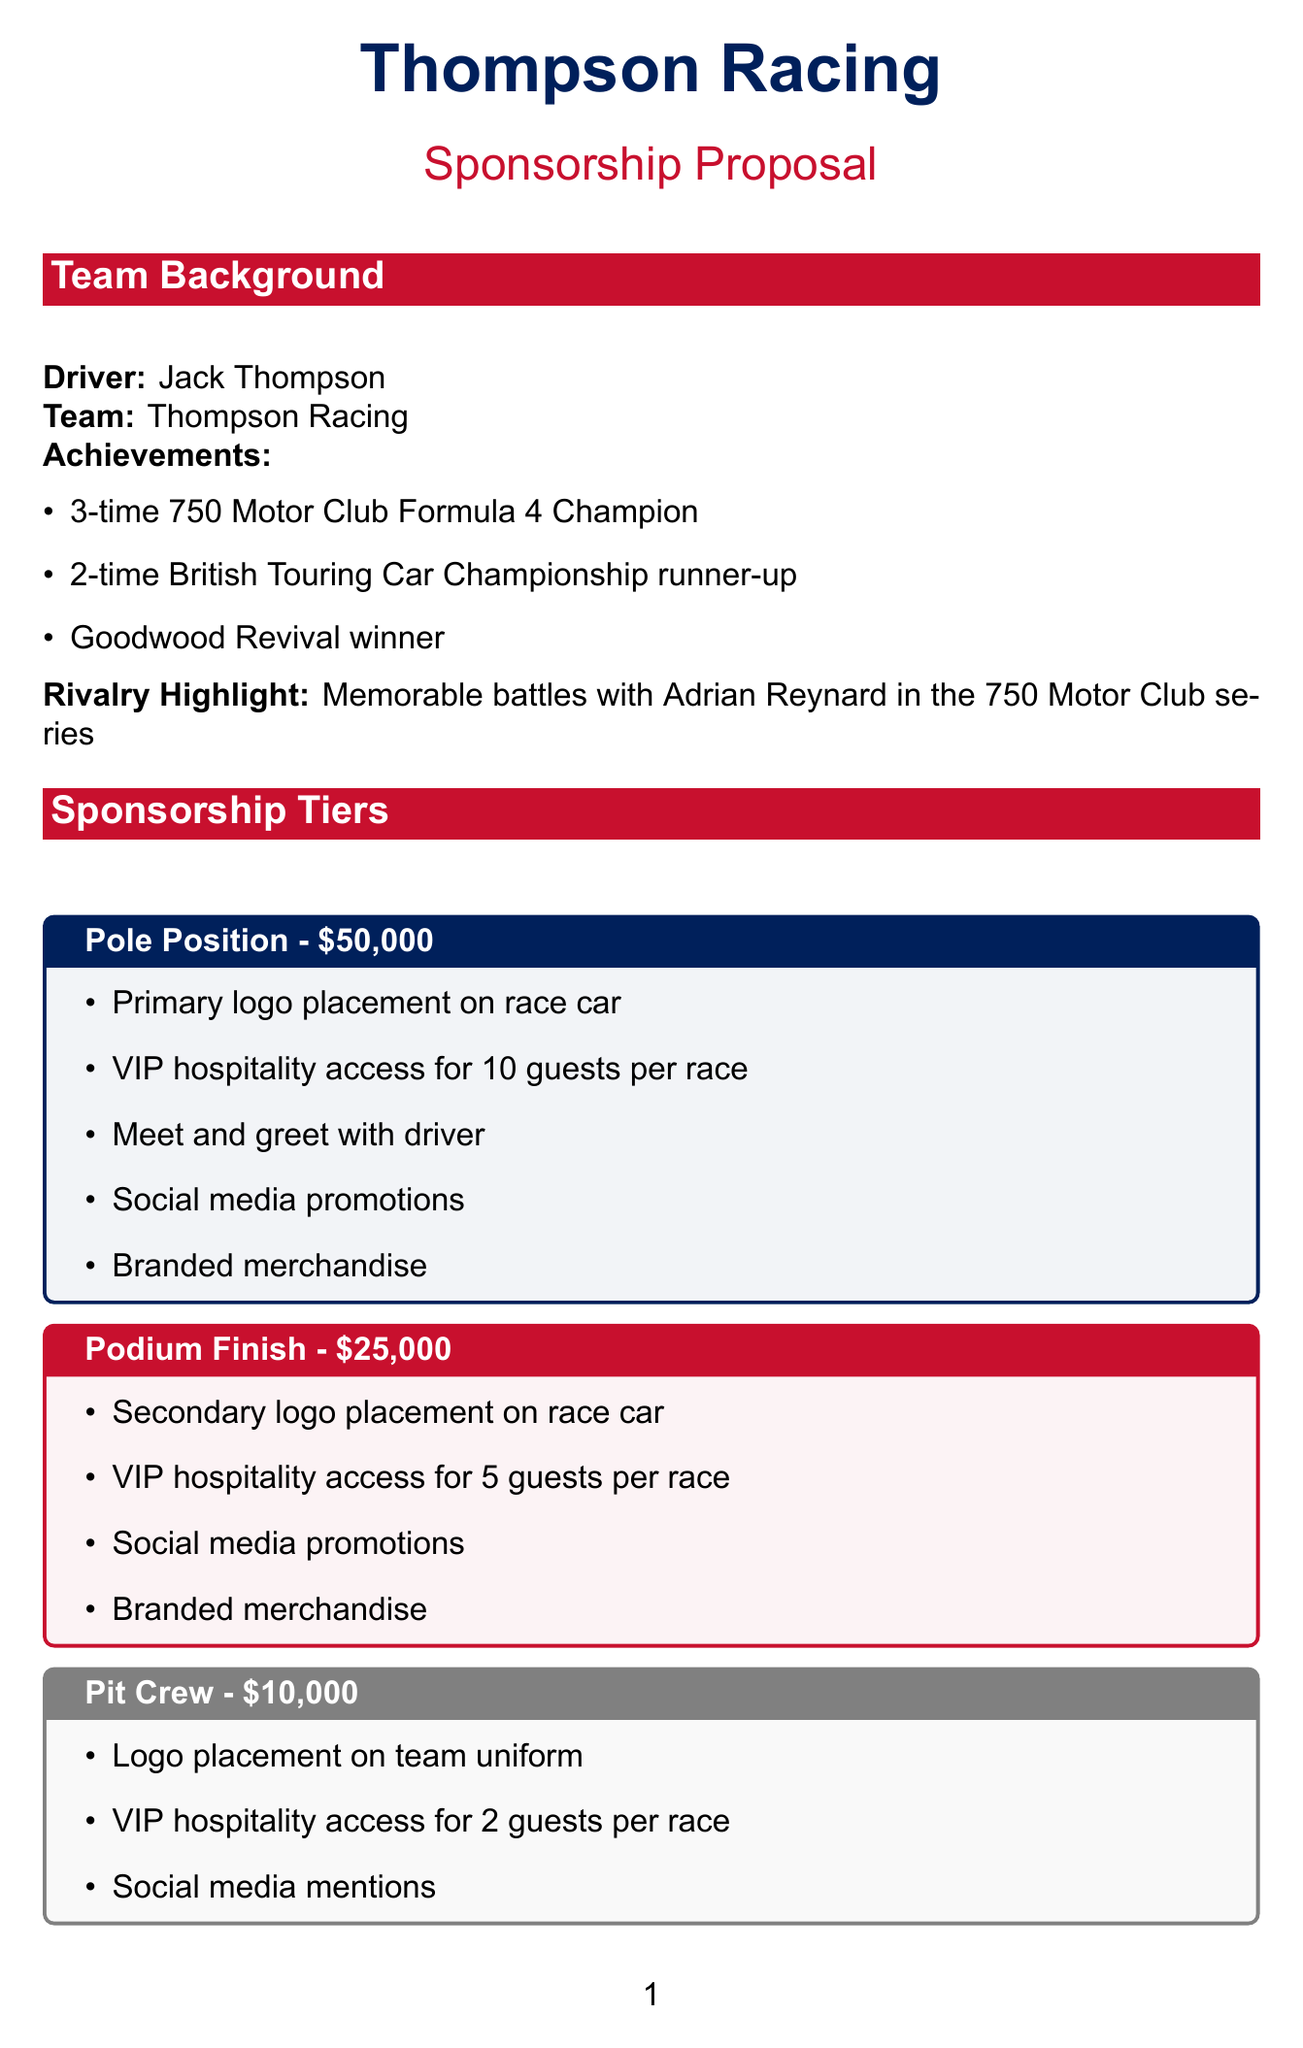What is the name of the driver? The document states that the driver's name is Jack Thompson.
Answer: Jack Thompson What is the price of the Pit Crew sponsorship tier? The Pit Crew sponsorship tier is listed at a price of $10,000.
Answer: $10,000 How many guests can the Pole Position tier access in VIP hospitality? The document specifies that the Pole Position tier allows VIP hospitality access for 10 guests per race.
Answer: 10 guests What is the estimated viewership for television media exposure? The estimated viewership for television media exposure mentioned in the document is 5,000,000.
Answer: 5,000,000 Which publications are included in print media exposure? The document lists Autosport Magazine and Motorsport News as the included publications.
Answer: Autosport Magazine, Motorsport News How many sponsorship goals are mentioned in the document? The document provides a list of four sponsorship goals.
Answer: 4 What is one of the additional opportunities mentioned? The document highlights several opportunities, one of which is the Tech Talk Series.
Answer: Tech Talk Series What size is the logo placement on the rear wing? The size specified for the logo placement on the rear wing is Small (12" x 12").
Answer: Small (12" x 12") Who had a memorable rivalry with the driver? The document indicates that Adrian Reynard had a memorable rivalry with Jack Thompson.
Answer: Adrian Reynard 